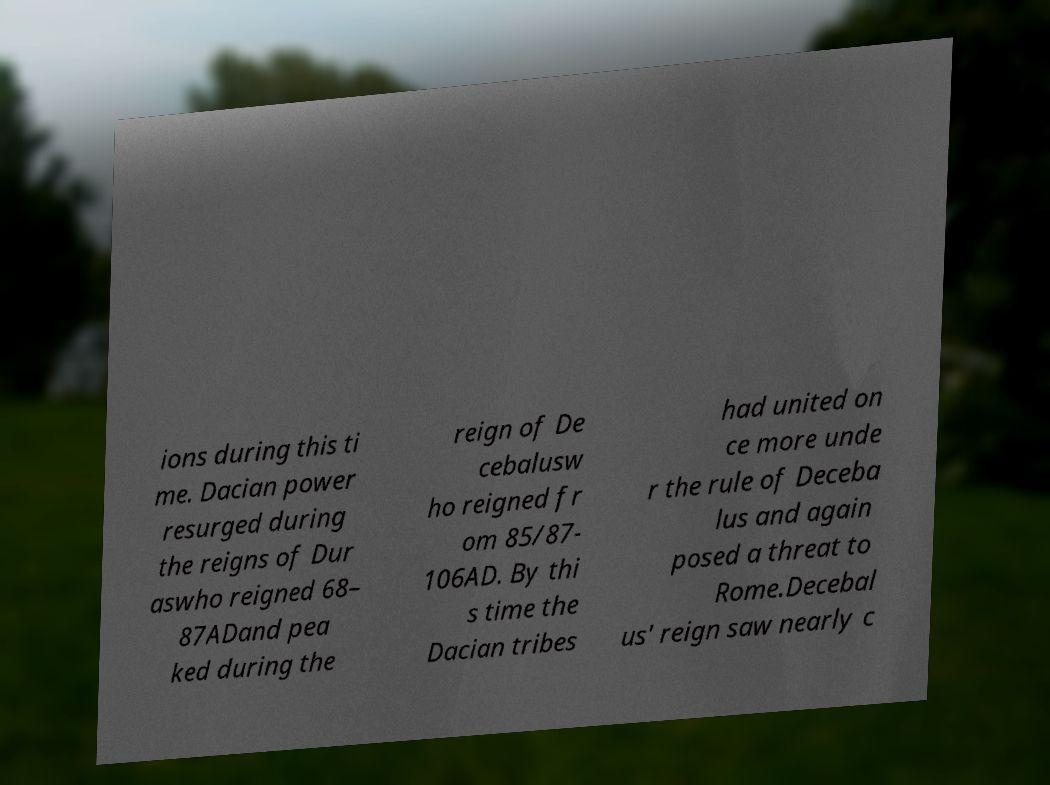Could you extract and type out the text from this image? ions during this ti me. Dacian power resurged during the reigns of Dur aswho reigned 68– 87ADand pea ked during the reign of De cebalusw ho reigned fr om 85/87- 106AD. By thi s time the Dacian tribes had united on ce more unde r the rule of Deceba lus and again posed a threat to Rome.Decebal us' reign saw nearly c 